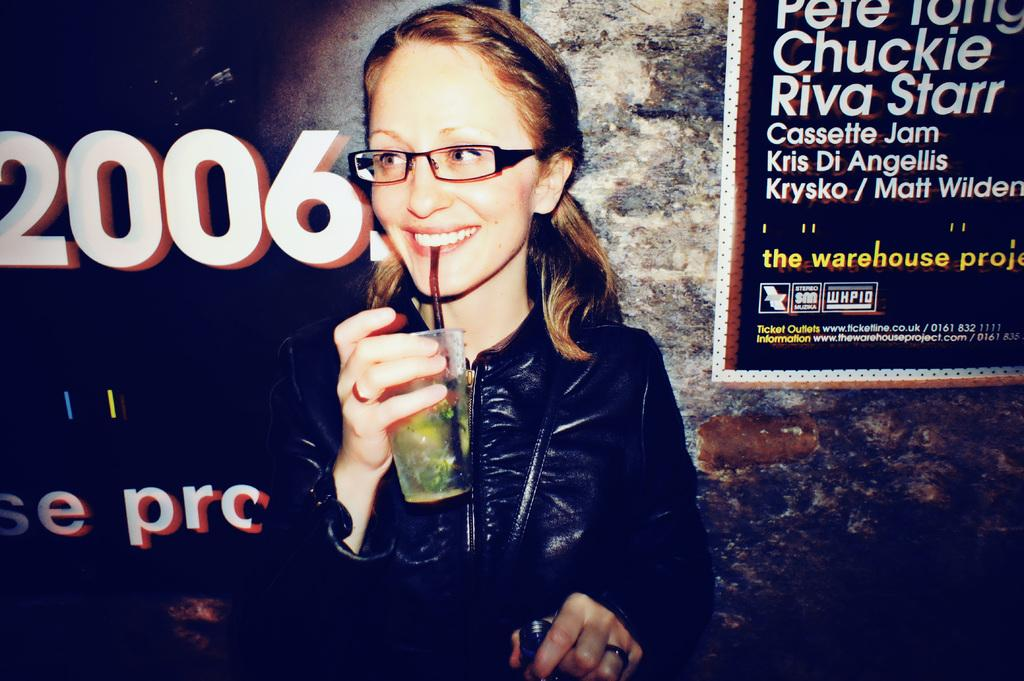Who is the main subject in the image? There is a girl in the image. What is the girl holding in the image? The girl is holding a glass. What can be seen in the background of the image? There is a wall in the background of the image. What is written on the banner in the image? There is a banner with some text in the image. What type of paint is being used to create humor in the image? There is no paint or humor present in the image; it features a girl holding a glass with a banner in the background. 